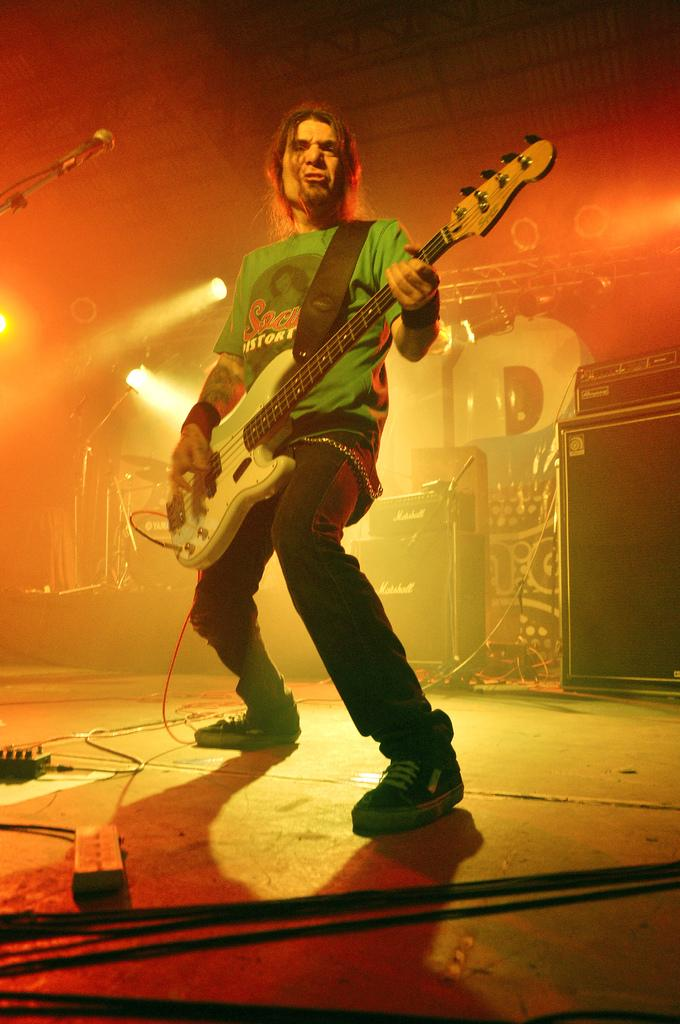What object is present in the image that is commonly used for amplifying sound? There is a microphone in the image. What can be seen in the image that provides illumination? There is a light in the image. What is the man in the image holding? The man in the image is holding a guitar. What type of detail can be seen in the caption of the image? There is no caption present in the image, so it is not possible to determine what type of detail might be seen in a caption. 